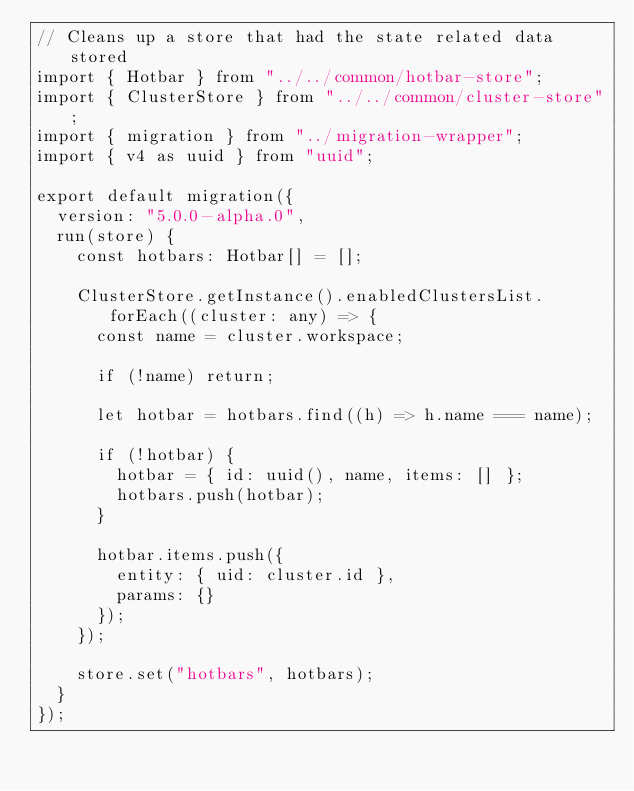<code> <loc_0><loc_0><loc_500><loc_500><_TypeScript_>// Cleans up a store that had the state related data stored
import { Hotbar } from "../../common/hotbar-store";
import { ClusterStore } from "../../common/cluster-store";
import { migration } from "../migration-wrapper";
import { v4 as uuid } from "uuid";

export default migration({
  version: "5.0.0-alpha.0",
  run(store) {
    const hotbars: Hotbar[] = [];

    ClusterStore.getInstance().enabledClustersList.forEach((cluster: any) => {
      const name = cluster.workspace;

      if (!name) return;

      let hotbar = hotbars.find((h) => h.name === name);

      if (!hotbar) {
        hotbar = { id: uuid(), name, items: [] };
        hotbars.push(hotbar);
      }

      hotbar.items.push({
        entity: { uid: cluster.id },
        params: {}
      });
    });

    store.set("hotbars", hotbars);
  }
});
</code> 